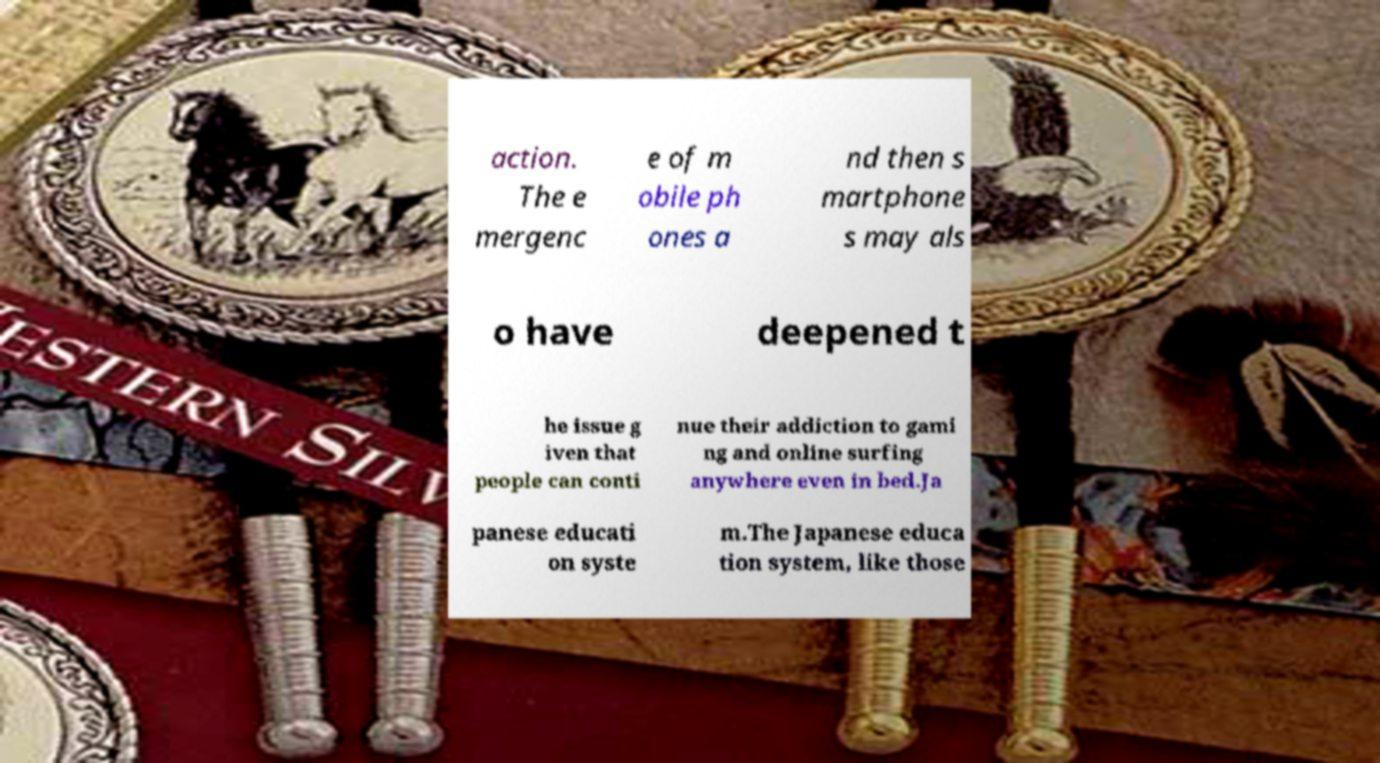Could you extract and type out the text from this image? action. The e mergenc e of m obile ph ones a nd then s martphone s may als o have deepened t he issue g iven that people can conti nue their addiction to gami ng and online surfing anywhere even in bed.Ja panese educati on syste m.The Japanese educa tion system, like those 